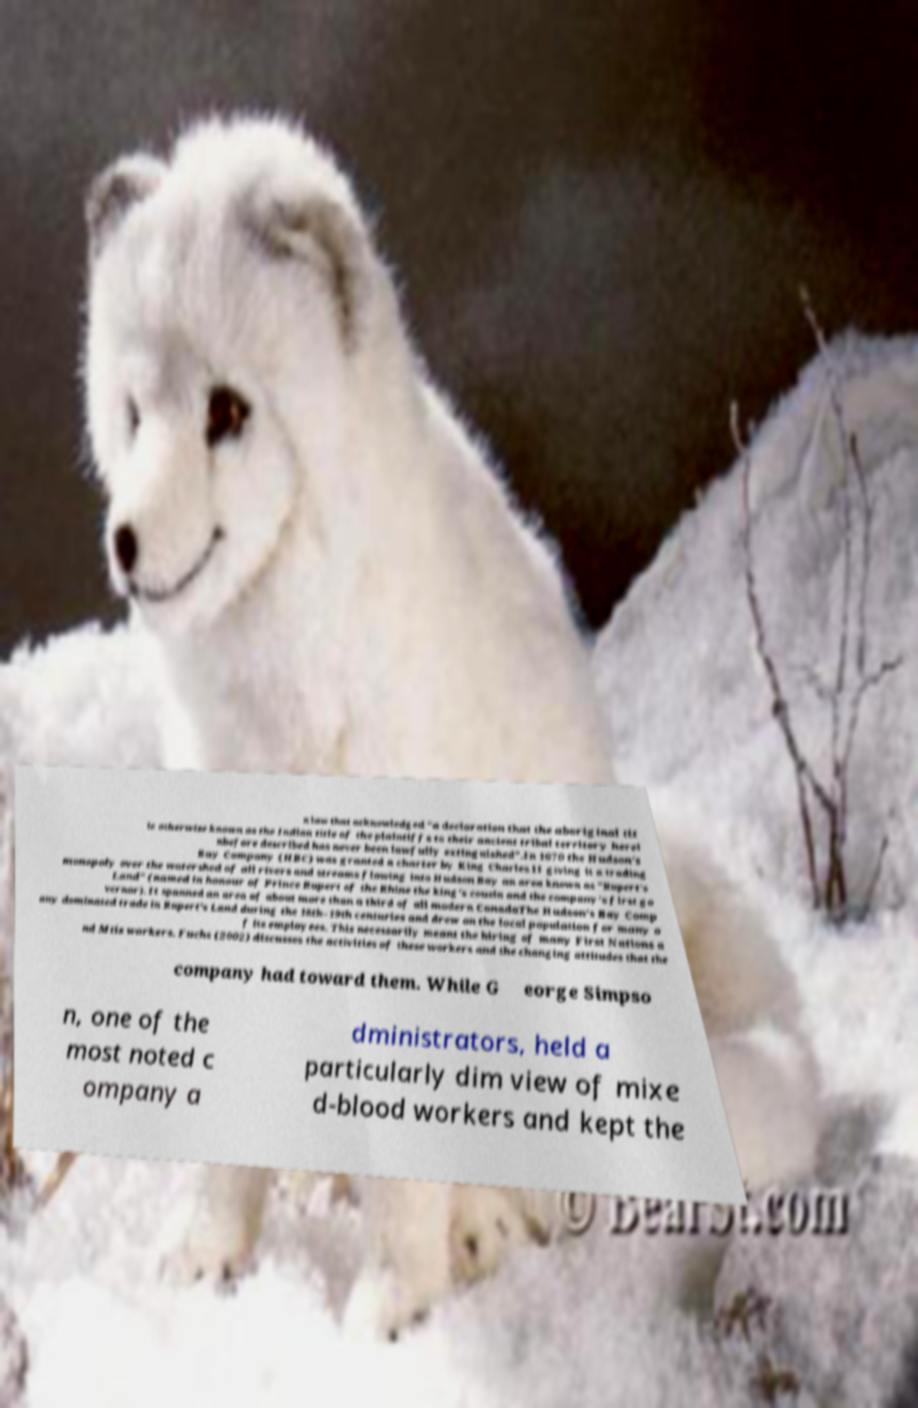Please read and relay the text visible in this image. What does it say? n law that acknowledged "a declaration that the aboriginal tit le otherwise known as the Indian title of the plaintiffs to their ancient tribal territory herei nbefore described has never been lawfully extinguished".In 1670 the Hudson's Bay Company (HBC) was granted a charter by King Charles II giving it a trading monopoly over the watershed of all rivers and streams flowing into Hudson Bay an area known as "Rupert's Land" (named in honour of Prince Rupert of the Rhine the king's cousin and the company's first go vernor). It spanned an area of about more than a third of all modern CanadaThe Hudson's Bay Comp any dominated trade in Rupert's Land during the 18th–19th centuries and drew on the local population for many o f its employees. This necessarily meant the hiring of many First Nations a nd Mtis workers. Fuchs (2002) discusses the activities of these workers and the changing attitudes that the company had toward them. While G eorge Simpso n, one of the most noted c ompany a dministrators, held a particularly dim view of mixe d-blood workers and kept the 